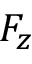Convert formula to latex. <formula><loc_0><loc_0><loc_500><loc_500>F _ { z }</formula> 